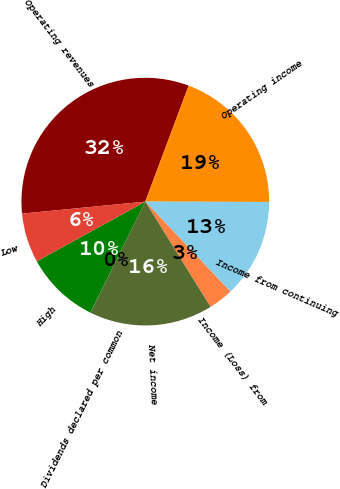<chart> <loc_0><loc_0><loc_500><loc_500><pie_chart><fcel>Operating revenues<fcel>Operating income<fcel>Income from continuing<fcel>Income (Loss) from<fcel>Net income<fcel>Dividends declared per common<fcel>High<fcel>Low<nl><fcel>32.24%<fcel>19.35%<fcel>12.9%<fcel>3.23%<fcel>16.13%<fcel>0.01%<fcel>9.68%<fcel>6.46%<nl></chart> 